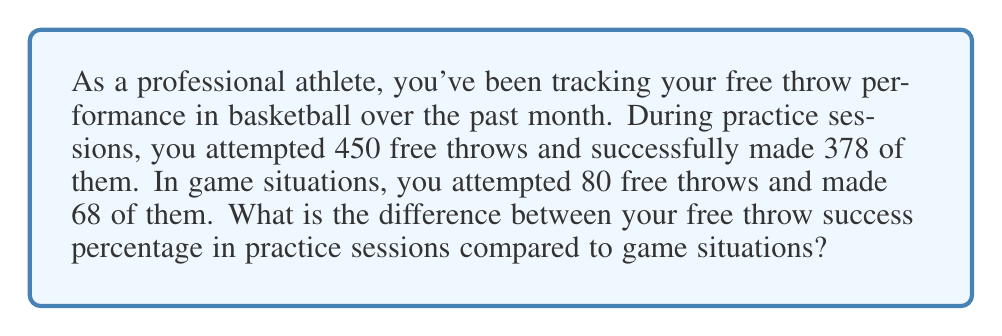Show me your answer to this math problem. Let's approach this problem step by step:

1. Calculate the success percentage for practice sessions:
   $$\text{Practice Success } \% = \frac{\text{Successful Attempts}}{\text{Total Attempts}} \times 100\%$$
   $$= \frac{378}{450} \times 100\%$$
   $$= 0.84 \times 100\% = 84\%$$

2. Calculate the success percentage for game situations:
   $$\text{Game Success } \% = \frac{\text{Successful Attempts}}{\text{Total Attempts}} \times 100\%$$
   $$= \frac{68}{80} \times 100\%$$
   $$= 0.85 \times 100\% = 85\%$$

3. Calculate the difference between the two percentages:
   $$\text{Difference } = \text{Game Success } \% - \text{Practice Success } \%$$
   $$= 85\% - 84\% = 1\%$$

The difference is positive, indicating that the success percentage in game situations is higher than in practice sessions.
Answer: The difference between the free throw success percentage in game situations compared to practice sessions is 1%, with game situations having a higher success rate. 